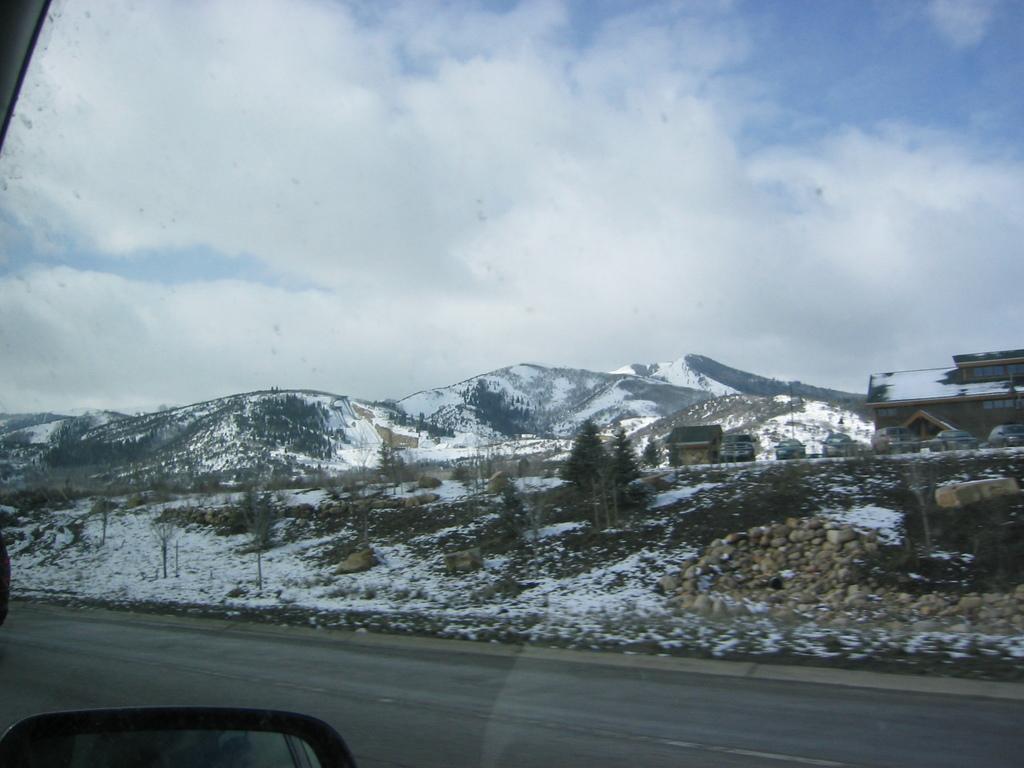Can you describe this image briefly? In the picture we can see from a car outside with roads, snow surface, plants, trees, and hills with snow on it and behind it we can see a sky with clouds. 